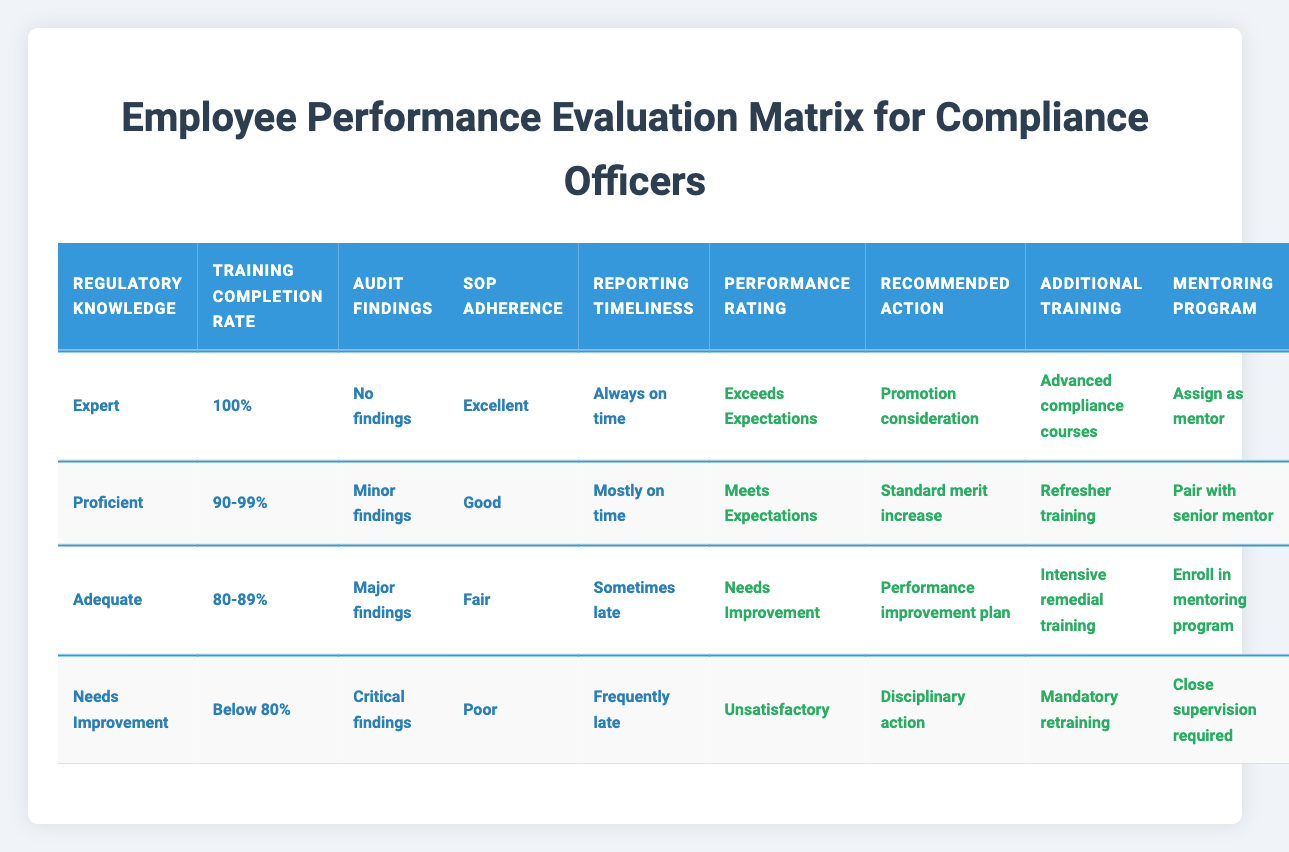What is the performance rating for an employee with Expert regulatory knowledge and 100% training completion? According to the table, the performance rating for an employee with Expert regulatory knowledge and 100% training completion is "Exceeds Expectations." This is found in the first row of the table.
Answer: Exceeds Expectations How many actions are recommended for an employee rated as "Unsatisfactory"? The table shows that for an employee rated "Unsatisfactory," there are four recommended actions listed: "Disciplinary action," "Mandatory retraining," "Close supervision required." Thus, the total number of actions is four.
Answer: 4 Is there an employee who meets expectations with a training completion rate of 90-99%? Yes, the table indicates that an employee with Proficient regulatory knowledge, a training completion rate of 90-99%, and minor findings is rated as "Meets Expectations." Hence, such an employee exists.
Answer: Yes What are the recommended actions for someone rated as "Needs Improvement"? For someone rated "Needs Improvement," the recommended actions include "Performance improvement plan," "Intensive remedial training," and "Enroll in mentoring program." These actions are detailed in the third row of the table.
Answer: Performance improvement plan, Intensive remedial training, Enroll in mentoring program If an employee has minor findings, what is their potential performance rating based on the table? An employee with minor findings and proficient regulatory knowledge, along with a 90-99% training completion rate and good SOP adherence, is rated as "Meets Expectations." Thus, the potential rating is "Meets Expectations."
Answer: Meets Expectations What percentage of the performance ratings leads to a promotion consideration? From the table, only the performance rating "Exceeds Expectations" leads to promotion consideration. This occurs in one out of four total ratings; thus, the percentage is 25%.
Answer: 25% How does SOP adherence affect the recommended training for an employee with major findings? According to the table, for an employee rated as "Needs Improvement" with major findings and fair SOP adherence, the recommended training is "Intensive remedial training." The level of SOP adherence directly correlates with the type of action recommended.
Answer: Intensive remedial training What is the difference in training completion rates between those rated as "Exceeds Expectations" and "Unsatisfactory"? The employee rated "Exceeds Expectations" has a training completion rate of 100%, while the one rated "Unsatisfactory" has a completion rate of "Below 80%." This indicates a difference of at least 20%. Therefore, the difference in completion rates is significant.
Answer: At least 20% 